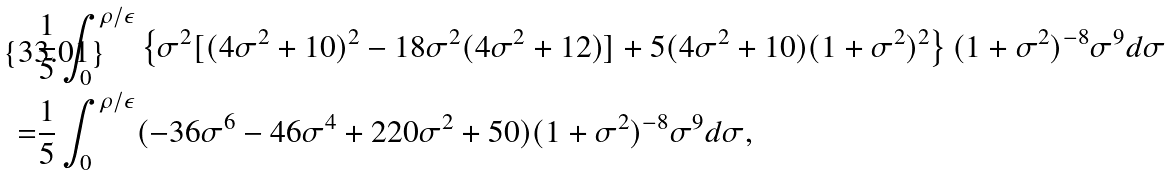Convert formula to latex. <formula><loc_0><loc_0><loc_500><loc_500>& \frac { 1 } { 5 } \int _ { 0 } ^ { \rho / \epsilon } \left \{ \sigma ^ { 2 } [ ( 4 \sigma ^ { 2 } + 1 0 ) ^ { 2 } - 1 8 \sigma ^ { 2 } ( 4 \sigma ^ { 2 } + 1 2 ) ] + 5 ( 4 \sigma ^ { 2 } + 1 0 ) ( 1 + \sigma ^ { 2 } ) ^ { 2 } \right \} ( 1 + \sigma ^ { 2 } ) ^ { - 8 } \sigma ^ { 9 } d \sigma \\ = & \frac { 1 } { 5 } \int _ { 0 } ^ { \rho / \epsilon } ( - 3 6 \sigma ^ { 6 } - 4 6 \sigma ^ { 4 } + 2 2 0 \sigma ^ { 2 } + 5 0 ) ( 1 + \sigma ^ { 2 } ) ^ { - 8 } \sigma ^ { 9 } d \sigma ,</formula> 